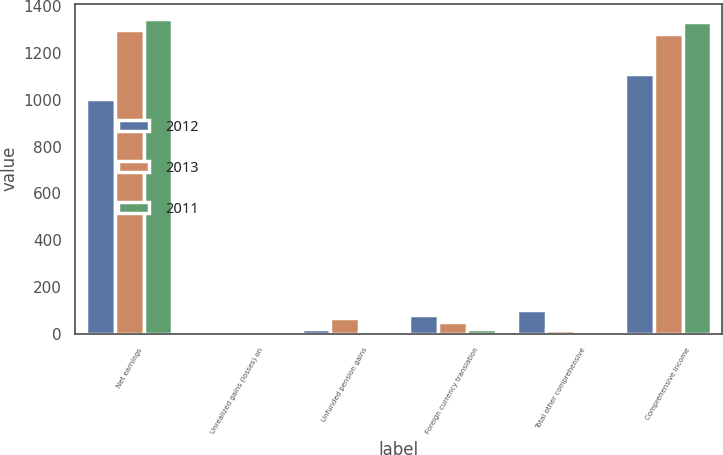Convert chart to OTSL. <chart><loc_0><loc_0><loc_500><loc_500><stacked_bar_chart><ecel><fcel>Net earnings<fcel>Unrealized gains (losses) on<fcel>Unfunded pension gains<fcel>Foreign currency translation<fcel>Total other comprehensive<fcel>Comprehensive income<nl><fcel>2012<fcel>1006<fcel>4<fcel>20<fcel>80<fcel>103<fcel>1109<nl><fcel>2013<fcel>1298<fcel>4<fcel>69<fcel>50<fcel>15<fcel>1283<nl><fcel>2011<fcel>1345<fcel>2<fcel>12<fcel>20<fcel>10<fcel>1335<nl></chart> 